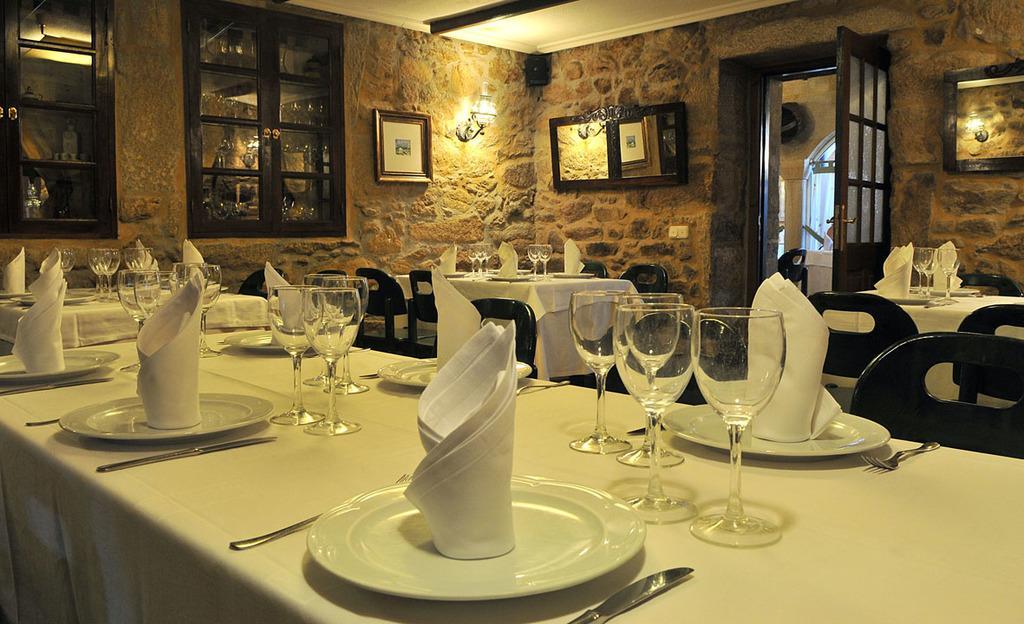Please provide a concise description of this image. In this image I can see many tables and chairs. On the tables I can see the plates and tissue papers. To the side there are many glasses, forks and knives. In the background I can see the boards and cupboards to the wall. I can also see the lights to the wall. 